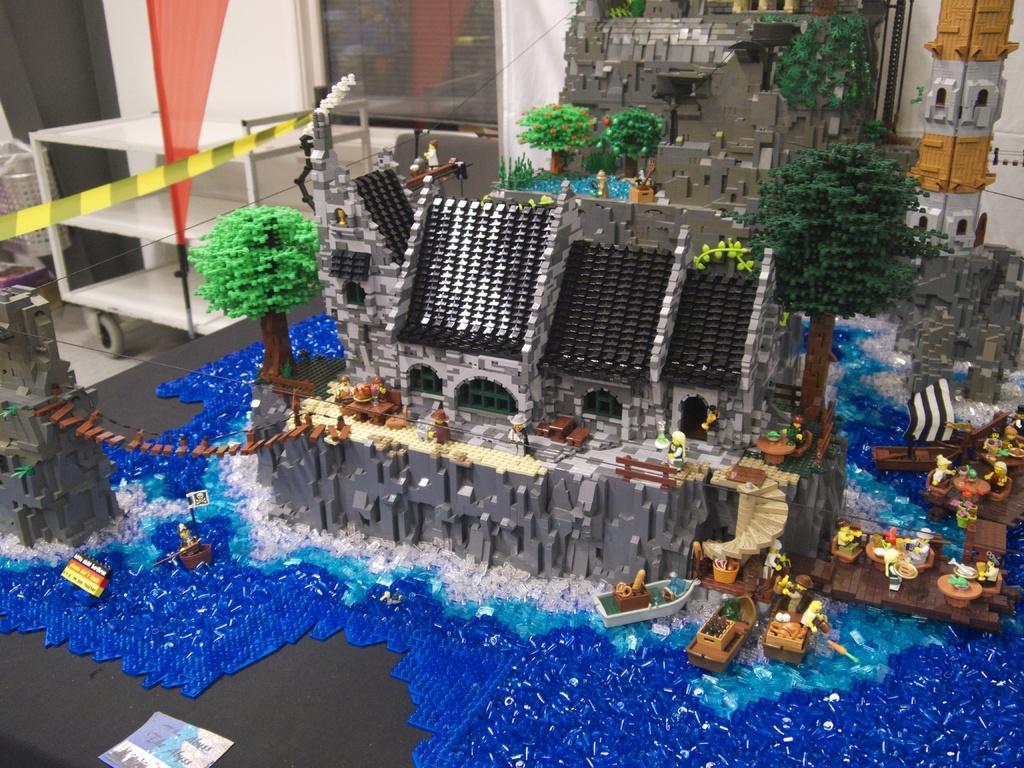Could you give a brief overview of what you see in this image? In this picture I can observe scale model of a building in the middle of the picture. In the background I can observe wall. 